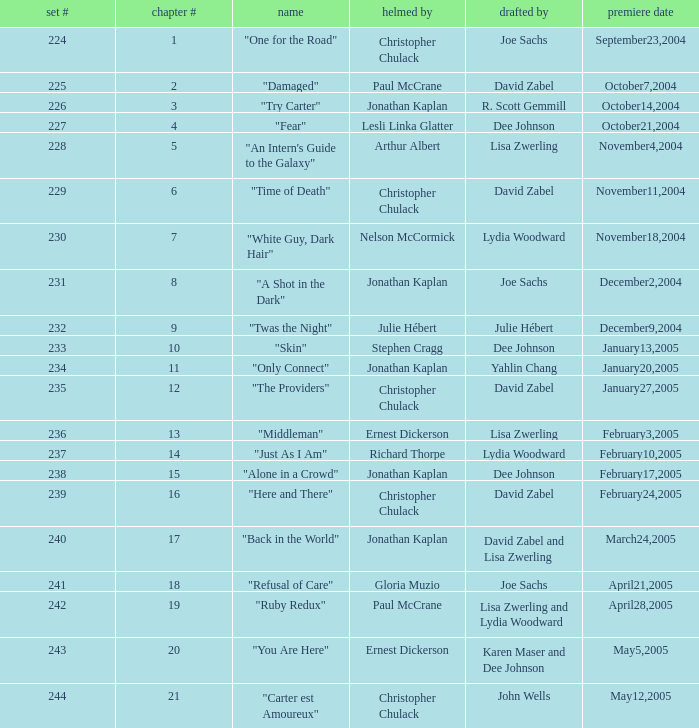Name the title that was written by r. scott gemmill "Try Carter". Parse the full table. {'header': ['set #', 'chapter #', 'name', 'helmed by', 'drafted by', 'premiere date'], 'rows': [['224', '1', '"One for the Road"', 'Christopher Chulack', 'Joe Sachs', 'September23,2004'], ['225', '2', '"Damaged"', 'Paul McCrane', 'David Zabel', 'October7,2004'], ['226', '3', '"Try Carter"', 'Jonathan Kaplan', 'R. Scott Gemmill', 'October14,2004'], ['227', '4', '"Fear"', 'Lesli Linka Glatter', 'Dee Johnson', 'October21,2004'], ['228', '5', '"An Intern\'s Guide to the Galaxy"', 'Arthur Albert', 'Lisa Zwerling', 'November4,2004'], ['229', '6', '"Time of Death"', 'Christopher Chulack', 'David Zabel', 'November11,2004'], ['230', '7', '"White Guy, Dark Hair"', 'Nelson McCormick', 'Lydia Woodward', 'November18,2004'], ['231', '8', '"A Shot in the Dark"', 'Jonathan Kaplan', 'Joe Sachs', 'December2,2004'], ['232', '9', '"Twas the Night"', 'Julie Hébert', 'Julie Hébert', 'December9,2004'], ['233', '10', '"Skin"', 'Stephen Cragg', 'Dee Johnson', 'January13,2005'], ['234', '11', '"Only Connect"', 'Jonathan Kaplan', 'Yahlin Chang', 'January20,2005'], ['235', '12', '"The Providers"', 'Christopher Chulack', 'David Zabel', 'January27,2005'], ['236', '13', '"Middleman"', 'Ernest Dickerson', 'Lisa Zwerling', 'February3,2005'], ['237', '14', '"Just As I Am"', 'Richard Thorpe', 'Lydia Woodward', 'February10,2005'], ['238', '15', '"Alone in a Crowd"', 'Jonathan Kaplan', 'Dee Johnson', 'February17,2005'], ['239', '16', '"Here and There"', 'Christopher Chulack', 'David Zabel', 'February24,2005'], ['240', '17', '"Back in the World"', 'Jonathan Kaplan', 'David Zabel and Lisa Zwerling', 'March24,2005'], ['241', '18', '"Refusal of Care"', 'Gloria Muzio', 'Joe Sachs', 'April21,2005'], ['242', '19', '"Ruby Redux"', 'Paul McCrane', 'Lisa Zwerling and Lydia Woodward', 'April28,2005'], ['243', '20', '"You Are Here"', 'Ernest Dickerson', 'Karen Maser and Dee Johnson', 'May5,2005'], ['244', '21', '"Carter est Amoureux"', 'Christopher Chulack', 'John Wells', 'May12,2005']]} 